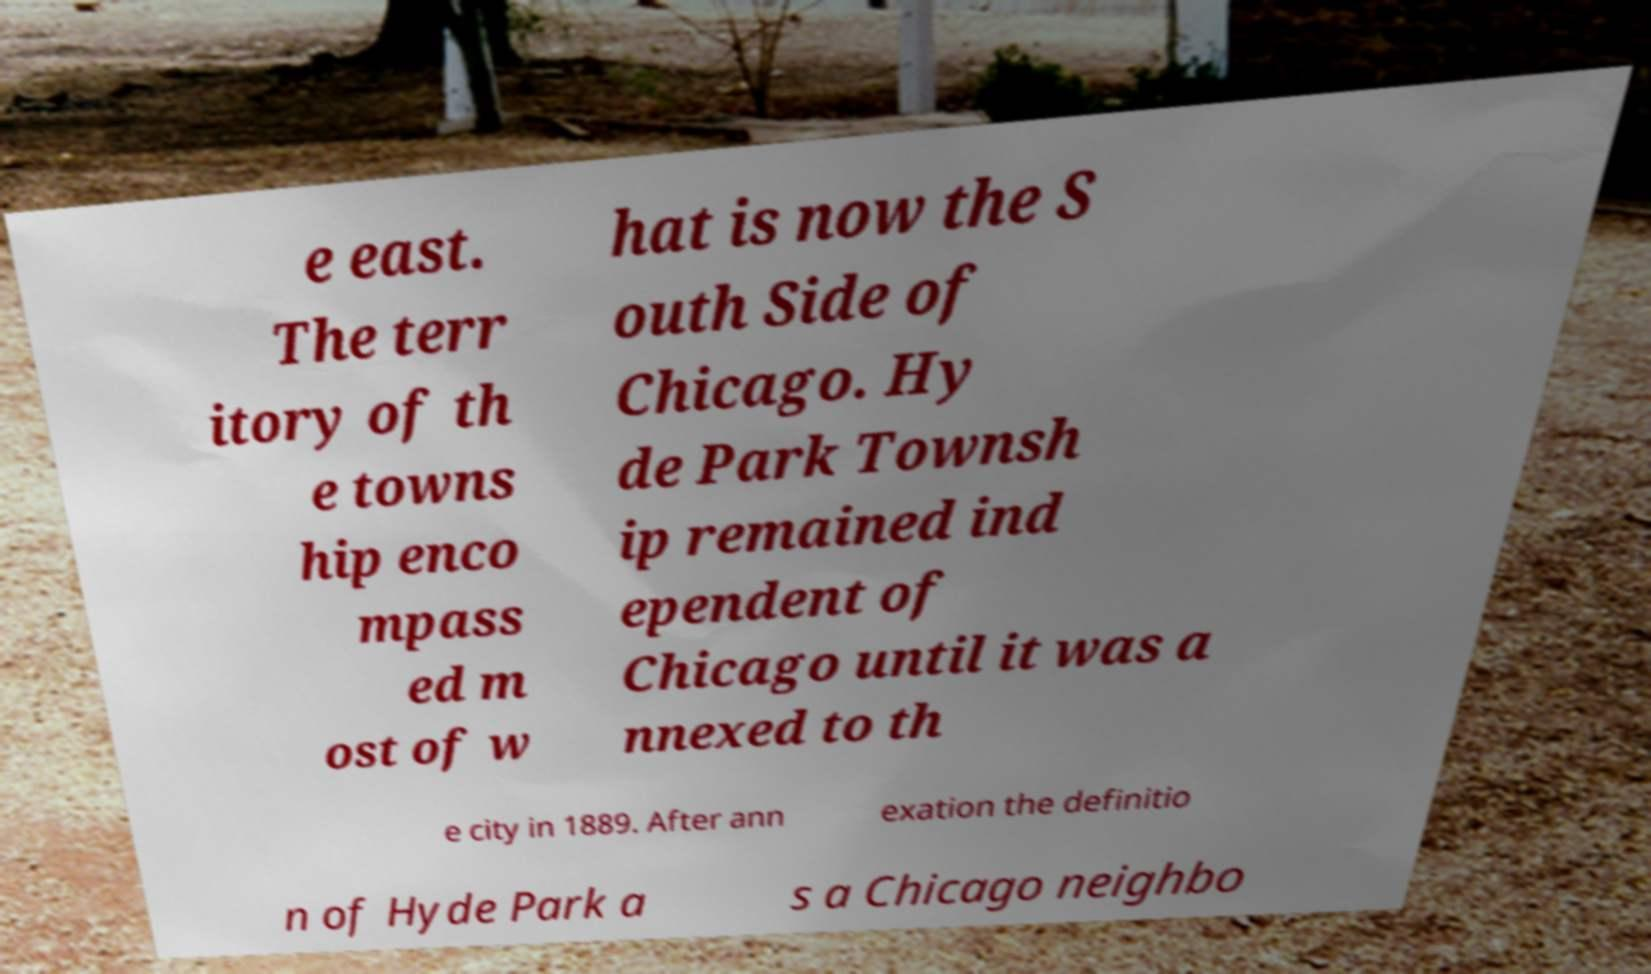Can you read and provide the text displayed in the image?This photo seems to have some interesting text. Can you extract and type it out for me? e east. The terr itory of th e towns hip enco mpass ed m ost of w hat is now the S outh Side of Chicago. Hy de Park Townsh ip remained ind ependent of Chicago until it was a nnexed to th e city in 1889. After ann exation the definitio n of Hyde Park a s a Chicago neighbo 